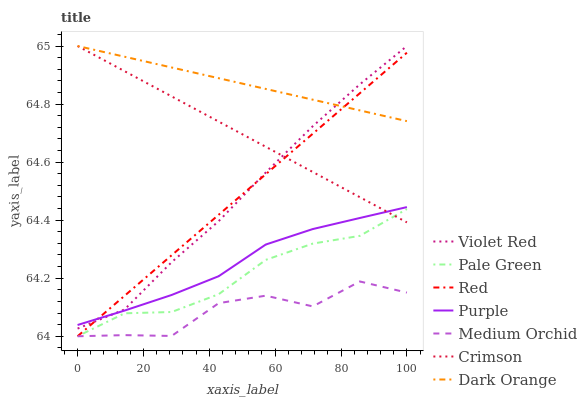Does Medium Orchid have the minimum area under the curve?
Answer yes or no. Yes. Does Dark Orange have the maximum area under the curve?
Answer yes or no. Yes. Does Violet Red have the minimum area under the curve?
Answer yes or no. No. Does Violet Red have the maximum area under the curve?
Answer yes or no. No. Is Dark Orange the smoothest?
Answer yes or no. Yes. Is Medium Orchid the roughest?
Answer yes or no. Yes. Is Violet Red the smoothest?
Answer yes or no. No. Is Violet Red the roughest?
Answer yes or no. No. Does Violet Red have the lowest value?
Answer yes or no. No. Does Crimson have the highest value?
Answer yes or no. Yes. Does Purple have the highest value?
Answer yes or no. No. Is Pale Green less than Purple?
Answer yes or no. Yes. Is Dark Orange greater than Medium Orchid?
Answer yes or no. Yes. Does Crimson intersect Dark Orange?
Answer yes or no. Yes. Is Crimson less than Dark Orange?
Answer yes or no. No. Is Crimson greater than Dark Orange?
Answer yes or no. No. Does Pale Green intersect Purple?
Answer yes or no. No. 